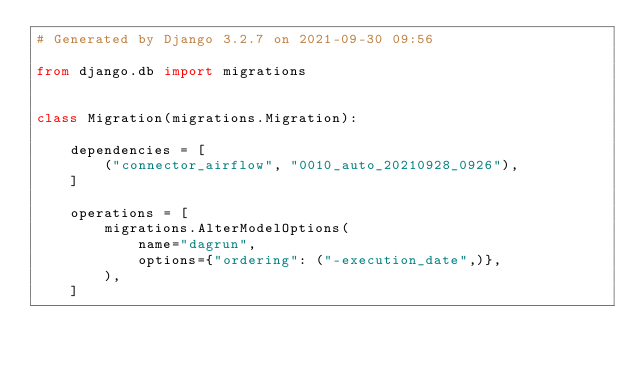Convert code to text. <code><loc_0><loc_0><loc_500><loc_500><_Python_># Generated by Django 3.2.7 on 2021-09-30 09:56

from django.db import migrations


class Migration(migrations.Migration):

    dependencies = [
        ("connector_airflow", "0010_auto_20210928_0926"),
    ]

    operations = [
        migrations.AlterModelOptions(
            name="dagrun",
            options={"ordering": ("-execution_date",)},
        ),
    ]
</code> 